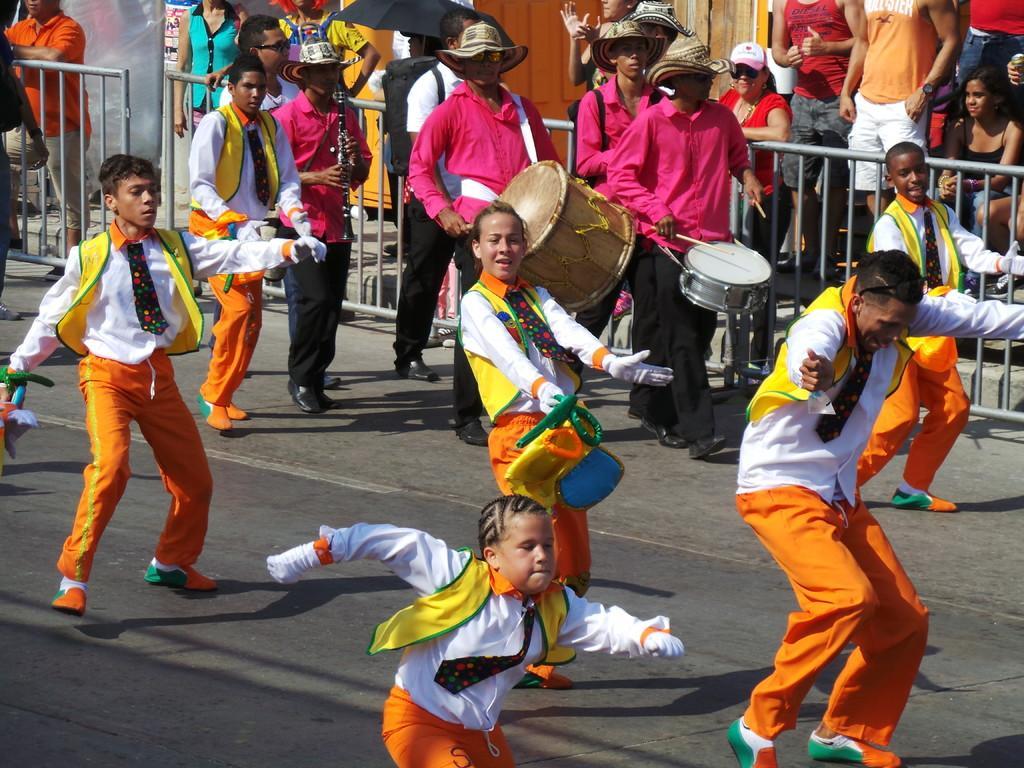Can you describe this image briefly? There are many people dancing on the road and some of them were playing drums on the side of the road. There is a railing behind them. In the background there are some people standing and watching at them. 